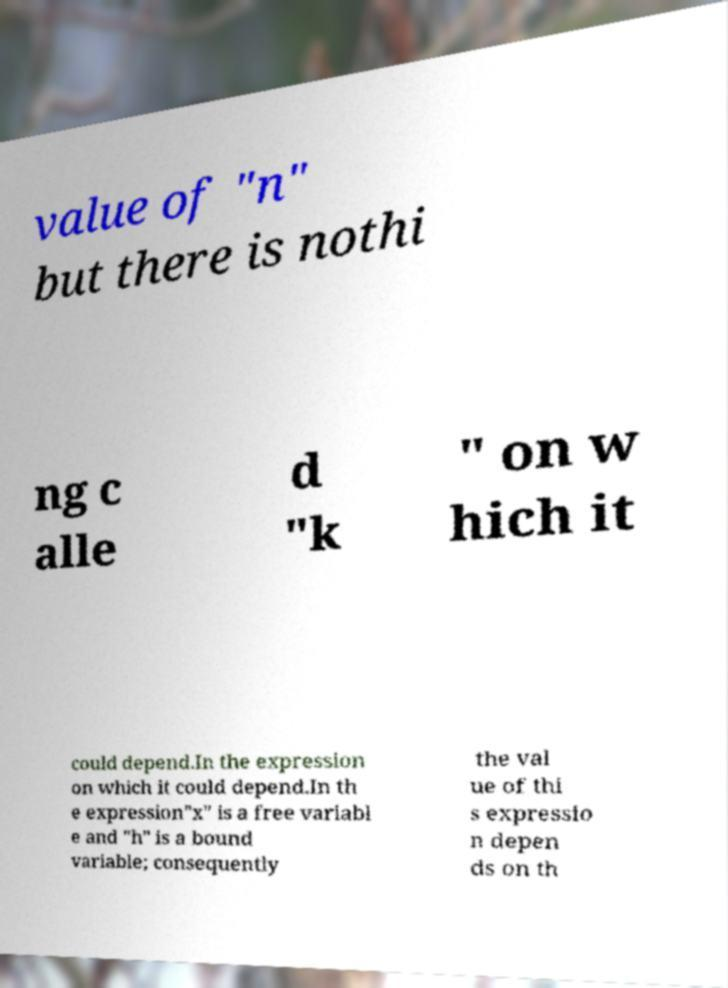Could you extract and type out the text from this image? value of "n" but there is nothi ng c alle d "k " on w hich it could depend.In the expression on which it could depend.In th e expression"x" is a free variabl e and "h" is a bound variable; consequently the val ue of thi s expressio n depen ds on th 